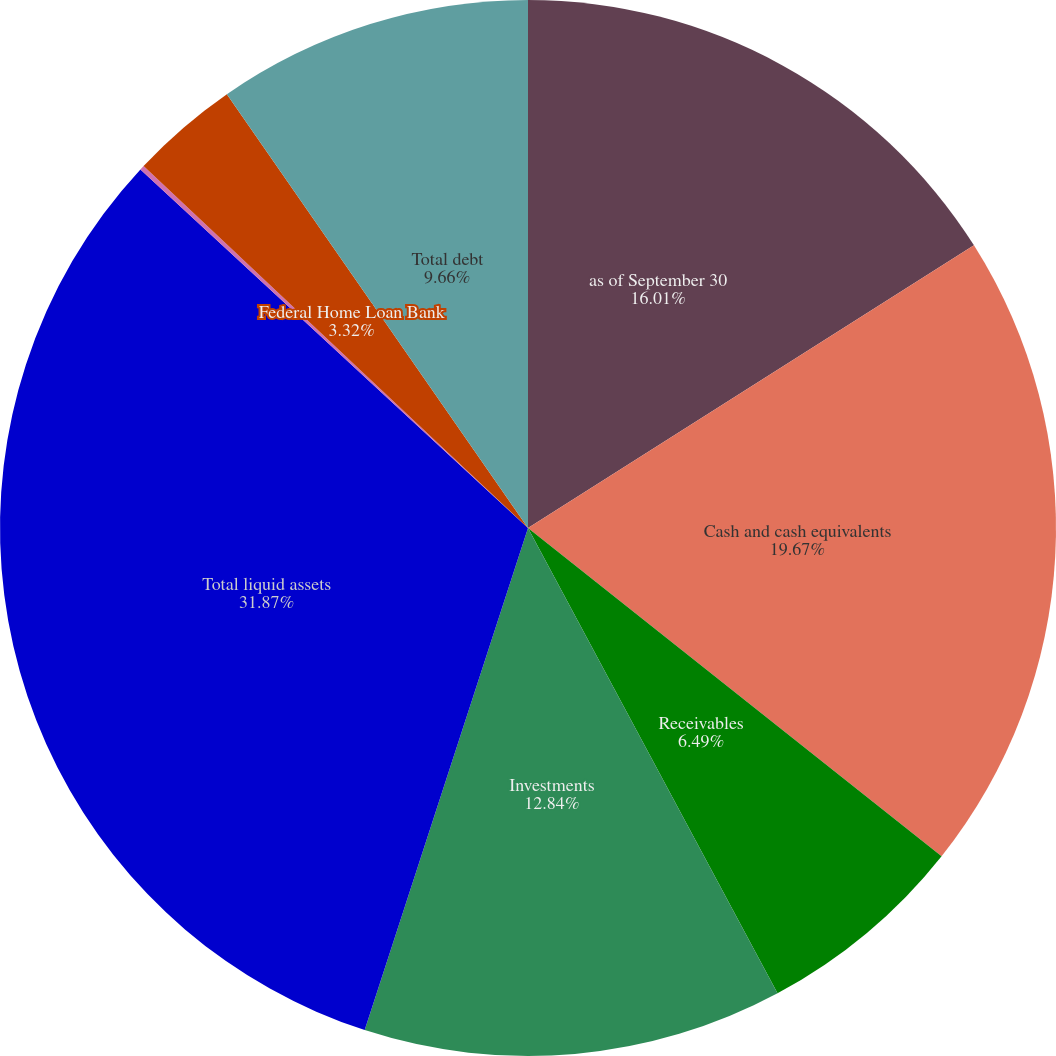Convert chart to OTSL. <chart><loc_0><loc_0><loc_500><loc_500><pie_chart><fcel>as of September 30<fcel>Cash and cash equivalents<fcel>Receivables<fcel>Investments<fcel>Total liquid assets<fcel>Commercial paper<fcel>Federal Home Loan Bank<fcel>Total debt<nl><fcel>16.01%<fcel>19.67%<fcel>6.49%<fcel>12.84%<fcel>31.88%<fcel>0.14%<fcel>3.32%<fcel>9.66%<nl></chart> 